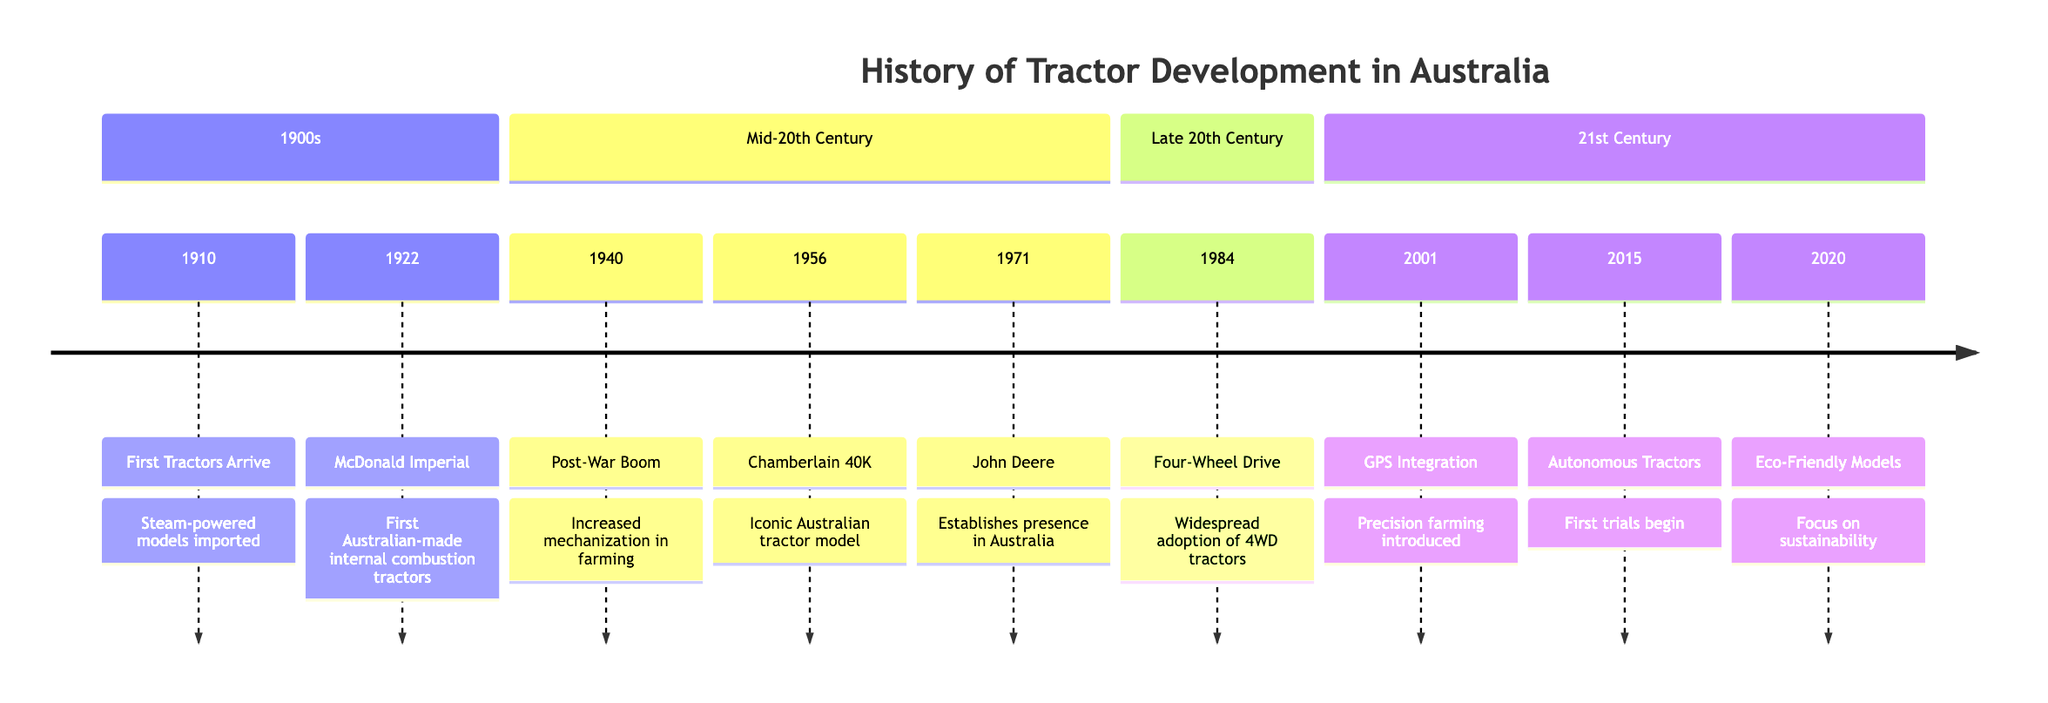What year did the first tractors arrive in Australia? According to the diagram, the first tractors arrived in Australia in 1910, as listed in the timeline.
Answer: 1910 What milestone occurred in 1922? The diagram indicates that the McDonald Imperial Internal Combustion Tractors milestone occurred in 1922.
Answer: McDonald Imperial How many milestones are listed in the late 20th century section? By reviewing the timeline, there is one milestone (the Four-Wheel Drive Tractors) listed in the late 20th century section.
Answer: 1 What technological advancement was introduced in 2001? The timeline shows that GPS technology integration into tractors was the key milestone introduced in 2001.
Answer: GPS Integration Which tractor model became iconic in Australian agriculture in 1956? The diagram specifies that the Chamberlain 40K model became iconic in 1956, marking its significance in Australian agriculture.
Answer: Chamberlain 40K What was a major change in farming after World War II according to the timeline? The timeline notes that the Post-War Mechanization Boom, which started in 1940, led to increased use of tractors in farming after World War II.
Answer: Increased use of tractors How many years passed between the introduction of GPS technology and the trials of autonomous tractors? From the diagram, GPS technology was introduced in 2001 and the trials of autonomous tractors began in 2015. The difference is 14 years.
Answer: 14 years Which milestone focuses on sustainability in the tractor industry? The timeline indicates that the milestone in 2020 emphasizes sustainable and energy-efficient models in the tractor industry.
Answer: Sustainable and Energy-Efficient Models What significant event happened in the year 1971 in the tractor industry? The diagram notes that in 1971, John Deere established its presence in Australia, marking a significant event in the tractor industry for that year.
Answer: John Deere Establishes Presence 